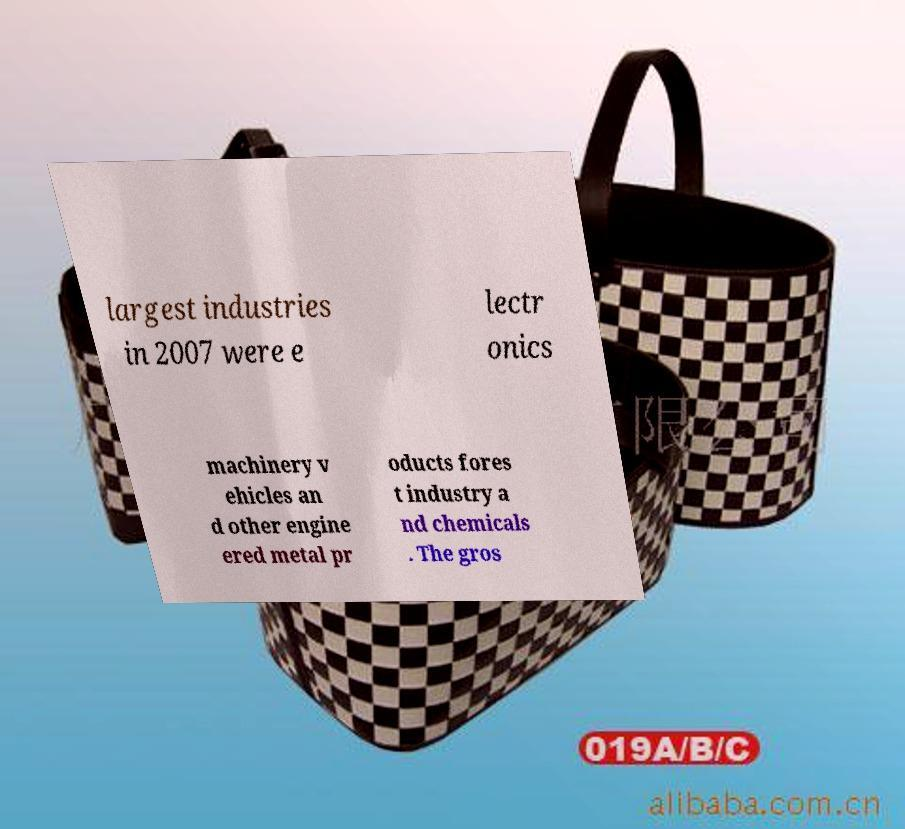Please identify and transcribe the text found in this image. largest industries in 2007 were e lectr onics machinery v ehicles an d other engine ered metal pr oducts fores t industry a nd chemicals . The gros 